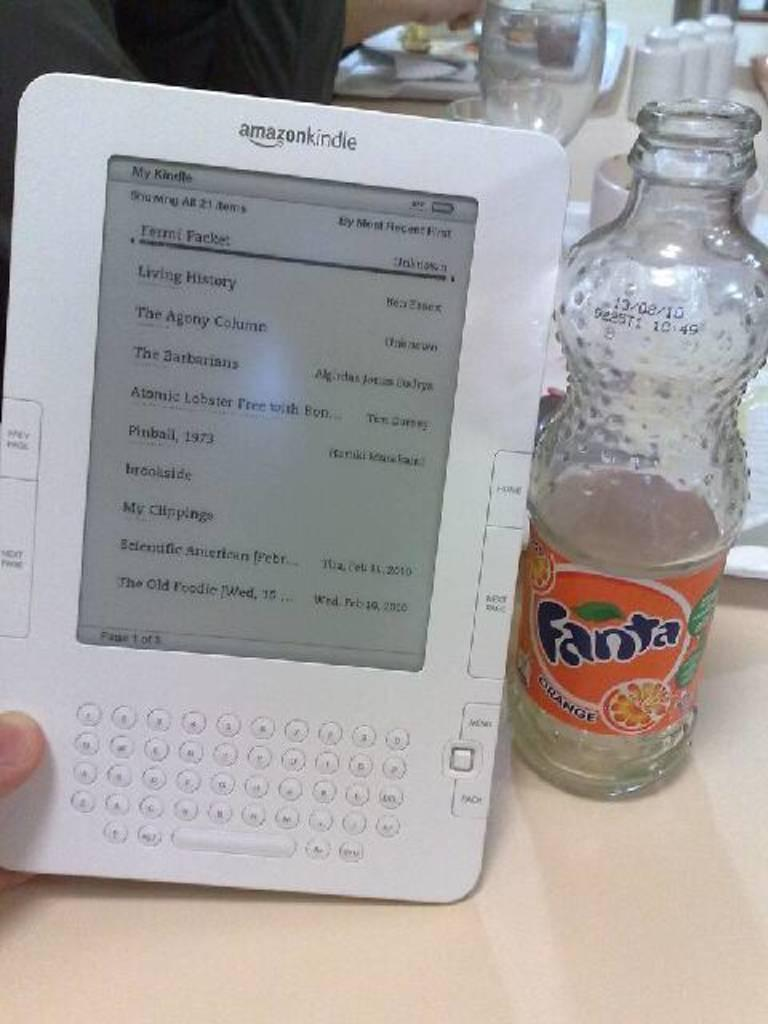What piece of furniture is present in the image? There is a table in the image. What is placed on the table? There is a plate, a glass, a bottle, and a tablet on the table. What might be used for drinking in the image? The glass on the table might be used for drinking. What might be used for reading or browsing in the image? The tablet on the table might be used for reading or browsing. What type of silverware is visible in the image? There is no silverware present in the image. What type of milk is being served in the glass in the image? There is no milk present in the image; only a glass is visible on the table. 